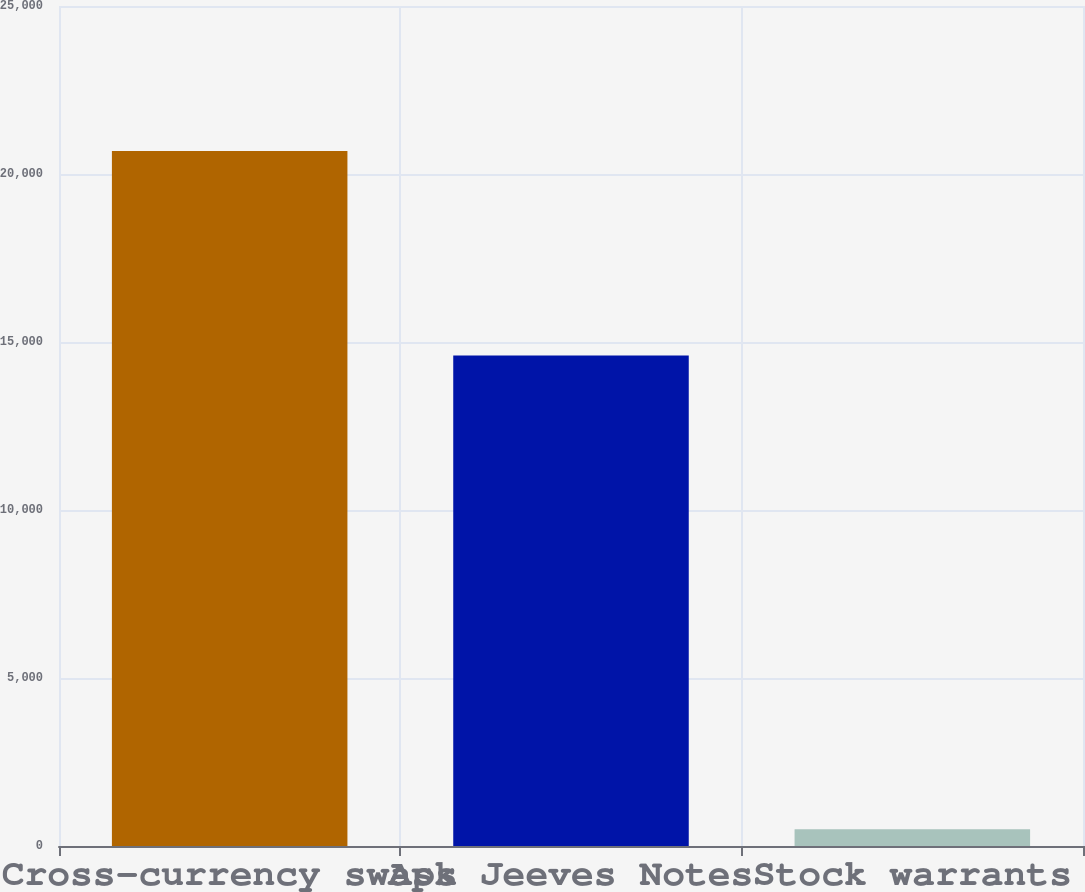Convert chart to OTSL. <chart><loc_0><loc_0><loc_500><loc_500><bar_chart><fcel>Cross-currency swaps<fcel>Ask Jeeves Notes<fcel>Stock warrants<nl><fcel>20682<fcel>14600<fcel>500<nl></chart> 